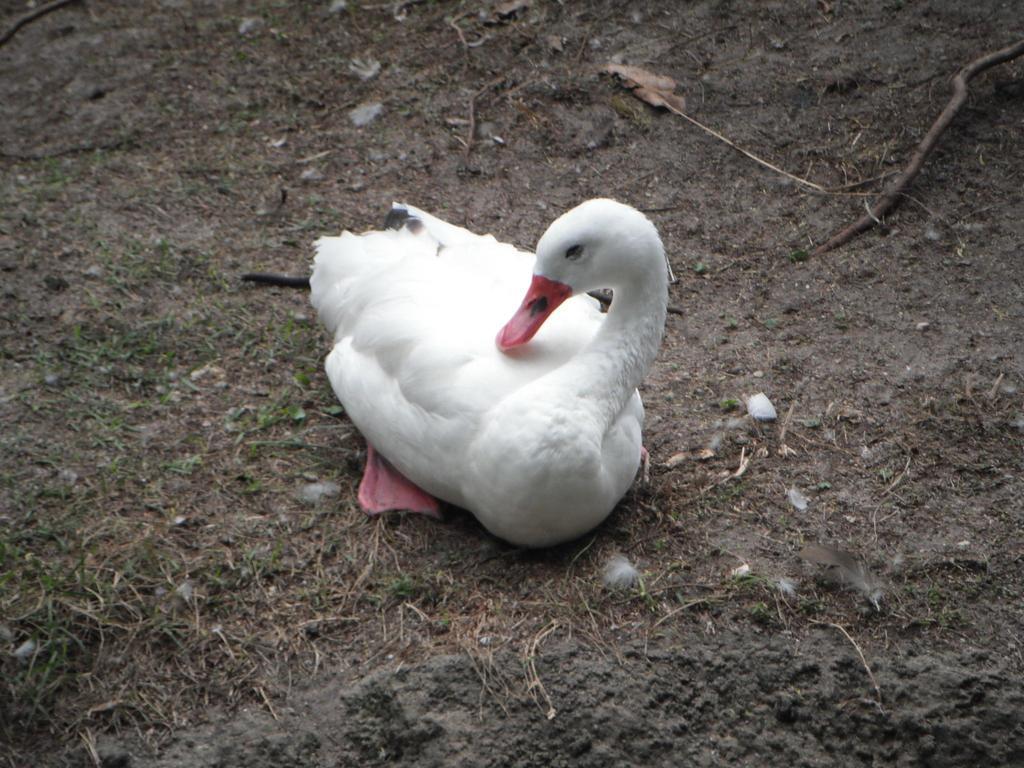Describe this image in one or two sentences. In this picture we can see a white color duck on the ground. 